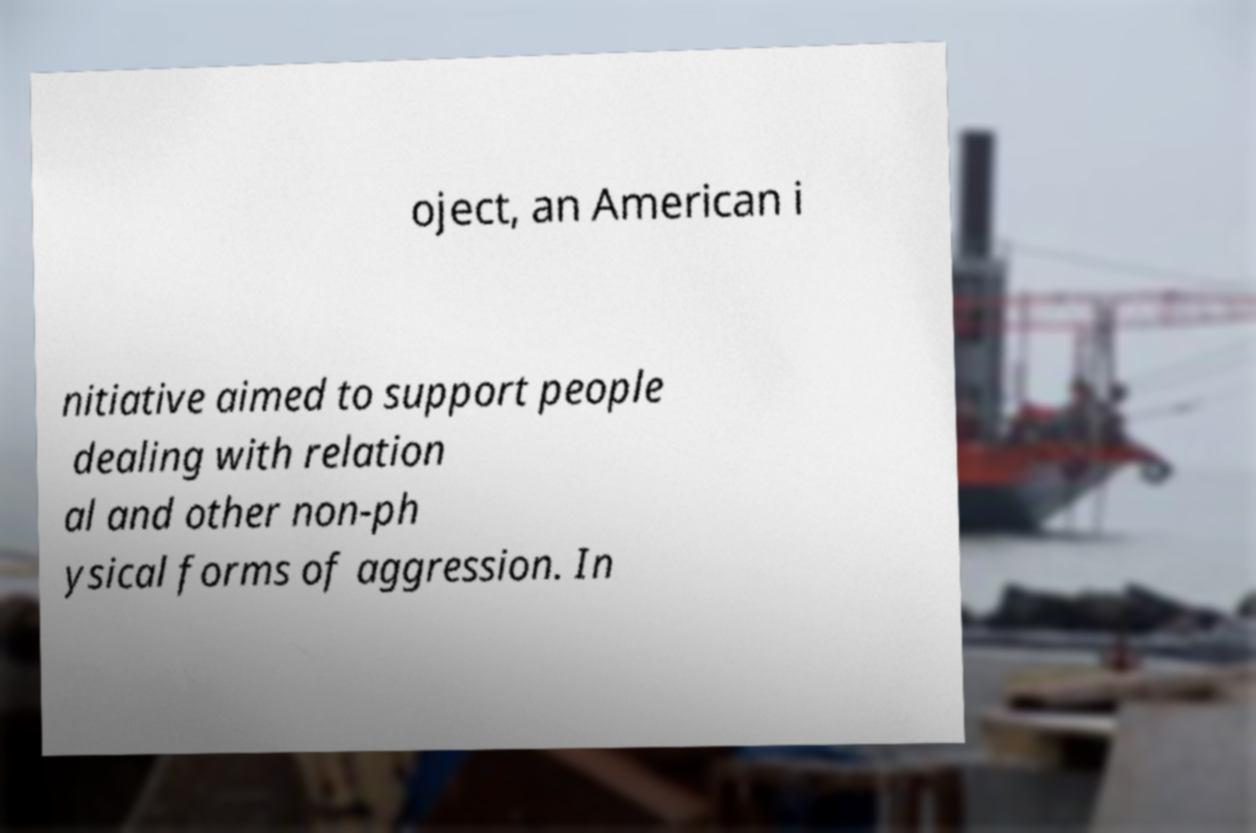There's text embedded in this image that I need extracted. Can you transcribe it verbatim? oject, an American i nitiative aimed to support people dealing with relation al and other non-ph ysical forms of aggression. In 